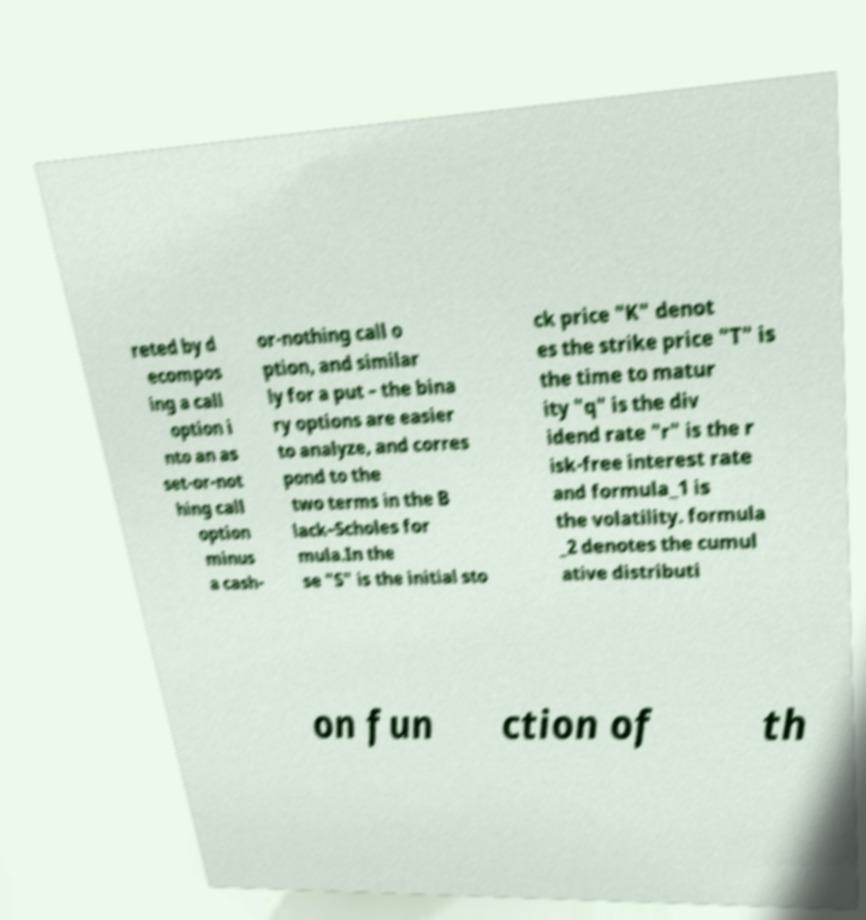There's text embedded in this image that I need extracted. Can you transcribe it verbatim? reted by d ecompos ing a call option i nto an as set-or-not hing call option minus a cash- or-nothing call o ption, and similar ly for a put – the bina ry options are easier to analyze, and corres pond to the two terms in the B lack–Scholes for mula.In the se "S" is the initial sto ck price "K" denot es the strike price "T" is the time to matur ity "q" is the div idend rate "r" is the r isk-free interest rate and formula_1 is the volatility. formula _2 denotes the cumul ative distributi on fun ction of th 